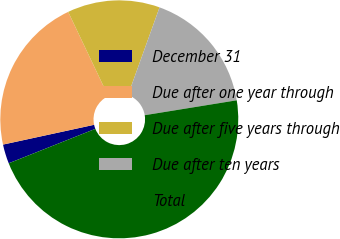Convert chart. <chart><loc_0><loc_0><loc_500><loc_500><pie_chart><fcel>December 31<fcel>Due after one year through<fcel>Due after five years through<fcel>Due after ten years<fcel>Total<nl><fcel>2.62%<fcel>21.34%<fcel>12.56%<fcel>16.95%<fcel>46.54%<nl></chart> 